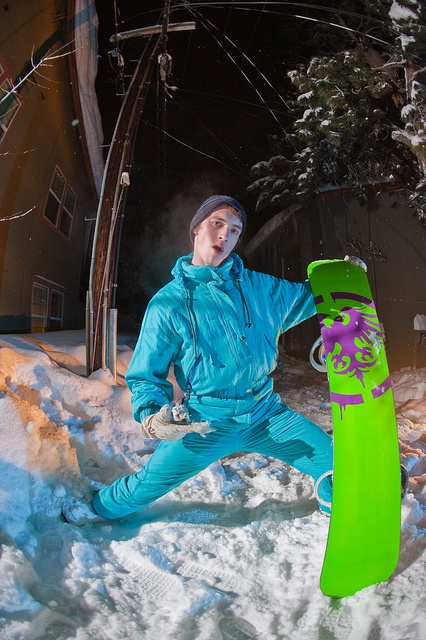Describe the objects in this image and their specific colors. I can see people in black, teal, and lightblue tones and snowboard in black, lime, darkgreen, and purple tones in this image. 